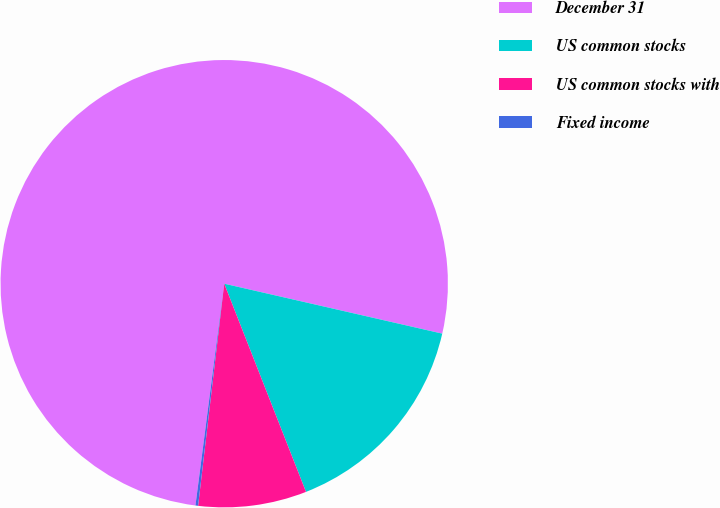Convert chart to OTSL. <chart><loc_0><loc_0><loc_500><loc_500><pie_chart><fcel>December 31<fcel>US common stocks<fcel>US common stocks with<fcel>Fixed income<nl><fcel>76.53%<fcel>15.46%<fcel>7.82%<fcel>0.19%<nl></chart> 